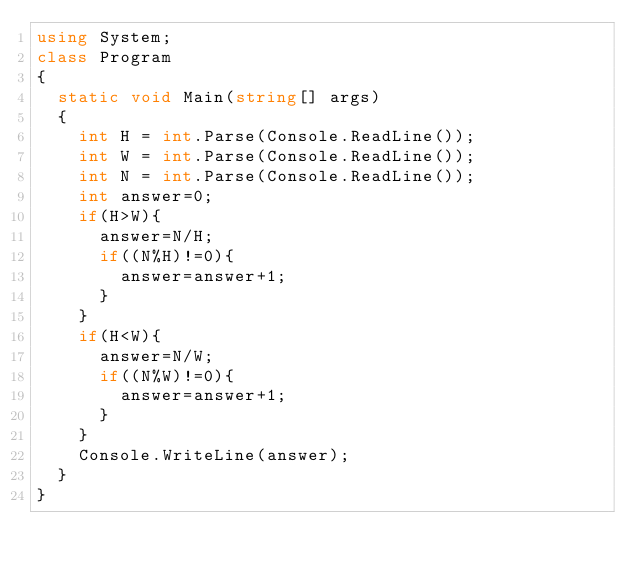<code> <loc_0><loc_0><loc_500><loc_500><_C#_>using System;
class Program
{
  static void Main(string[] args)
  {
    int H = int.Parse(Console.ReadLine());
    int W = int.Parse(Console.ReadLine());
    int N = int.Parse(Console.ReadLine());
    int answer=0;
    if(H>W){
      answer=N/H;
      if((N%H)!=0){
        answer=answer+1;
      }
    }
    if(H<W){
      answer=N/W;
      if((N%W)!=0){
        answer=answer+1;
      }
    }
    Console.WriteLine(answer);
  }
}</code> 